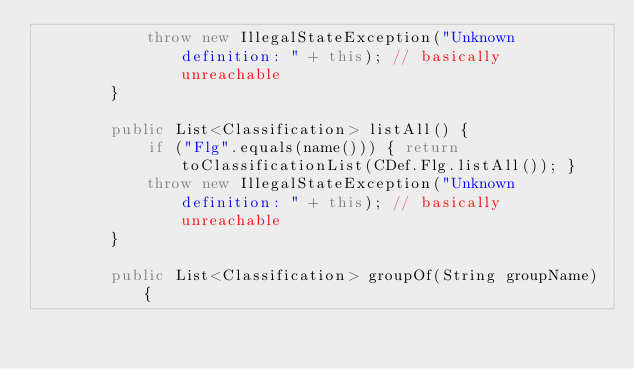<code> <loc_0><loc_0><loc_500><loc_500><_Java_>            throw new IllegalStateException("Unknown definition: " + this); // basically unreachable
        }

        public List<Classification> listAll() {
            if ("Flg".equals(name())) { return toClassificationList(CDef.Flg.listAll()); }
            throw new IllegalStateException("Unknown definition: " + this); // basically unreachable
        }

        public List<Classification> groupOf(String groupName) {</code> 